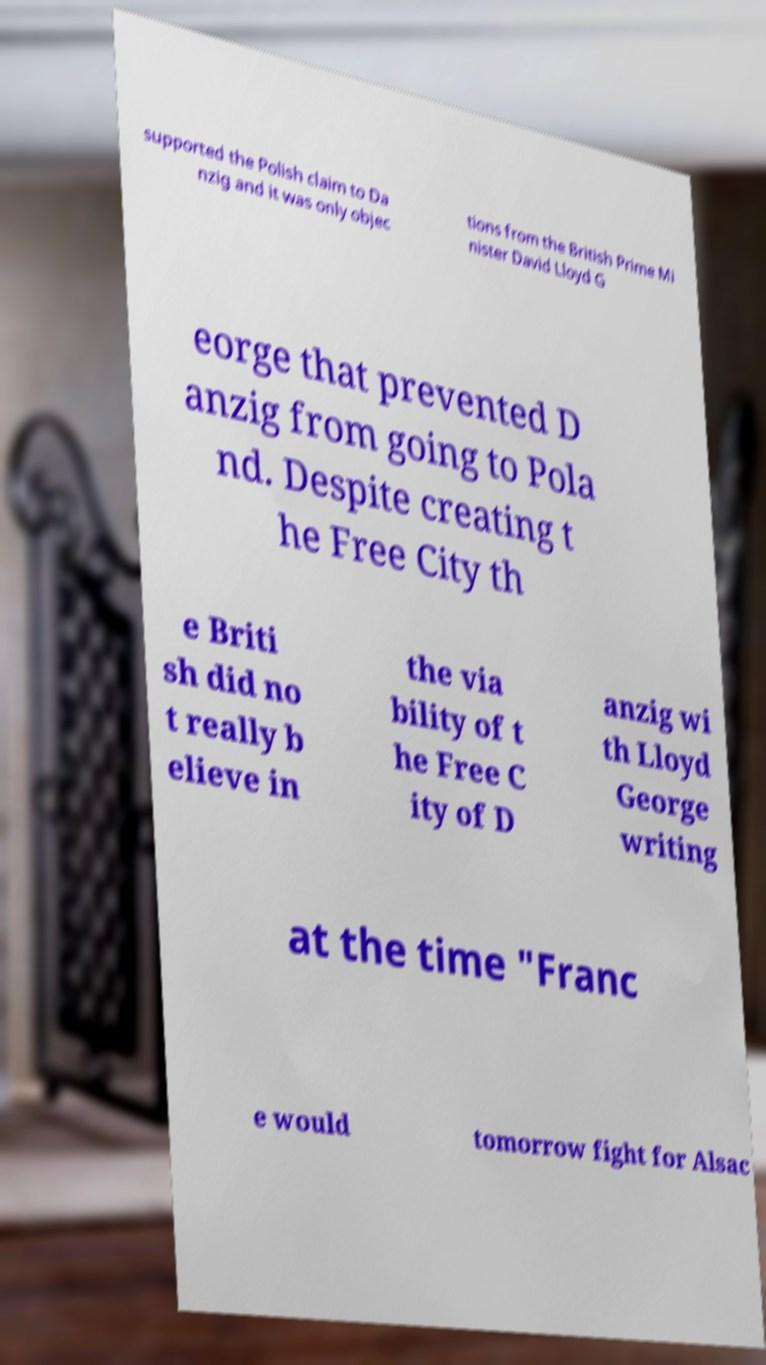Can you accurately transcribe the text from the provided image for me? supported the Polish claim to Da nzig and it was only objec tions from the British Prime Mi nister David Lloyd G eorge that prevented D anzig from going to Pola nd. Despite creating t he Free City th e Briti sh did no t really b elieve in the via bility of t he Free C ity of D anzig wi th Lloyd George writing at the time "Franc e would tomorrow fight for Alsac 